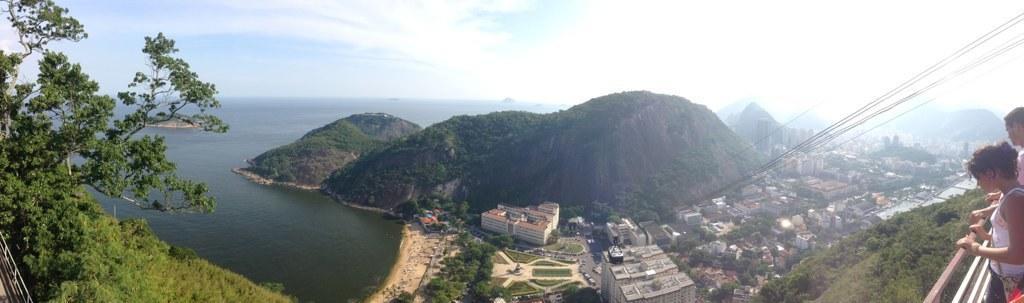In one or two sentences, can you explain what this image depicts? In the picture I can see these two persons are standing near the steel railing which is on the right side of the image. Here I can see ropes, ropeway, buildings, hills, trees, the water and the sky with clouds in the background. 